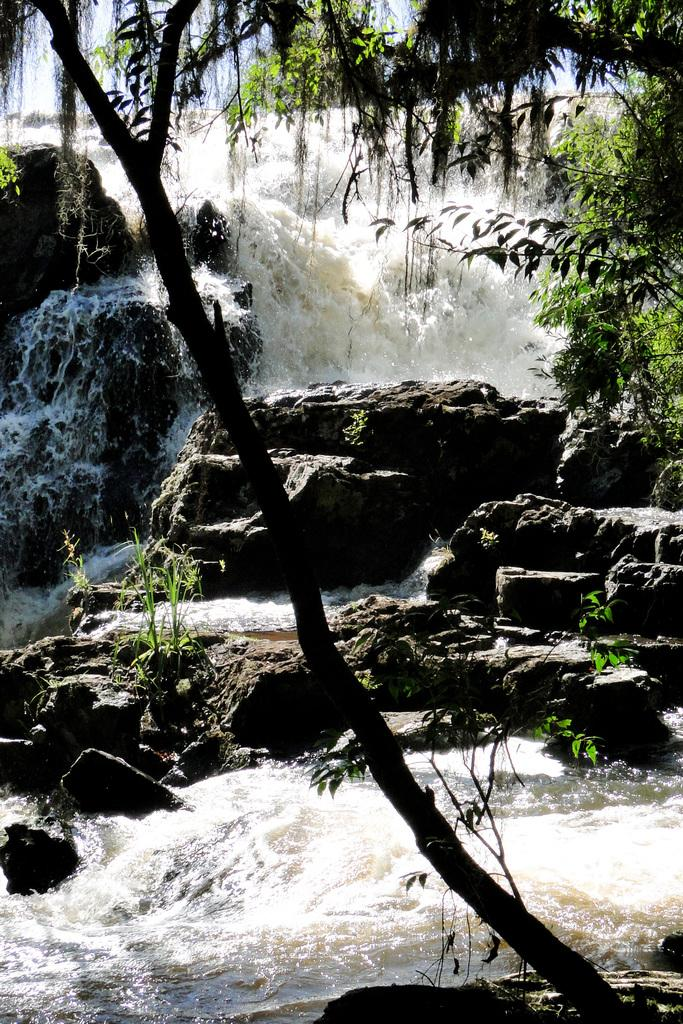What type of natural features can be seen in the image? There are trees and a waterfall in the image. Where is the waterfall located? The waterfall is on mountains. What is visible at the top of the image? The sky is visible at the top of the image. When was the image taken? The image was taken during the day. What type of faucet can be seen in the image? There is no faucet present in the image. What kind of polish is being applied to the trees in the image? There is no polish being applied to the trees in the image; they are natural trees in their original state. 